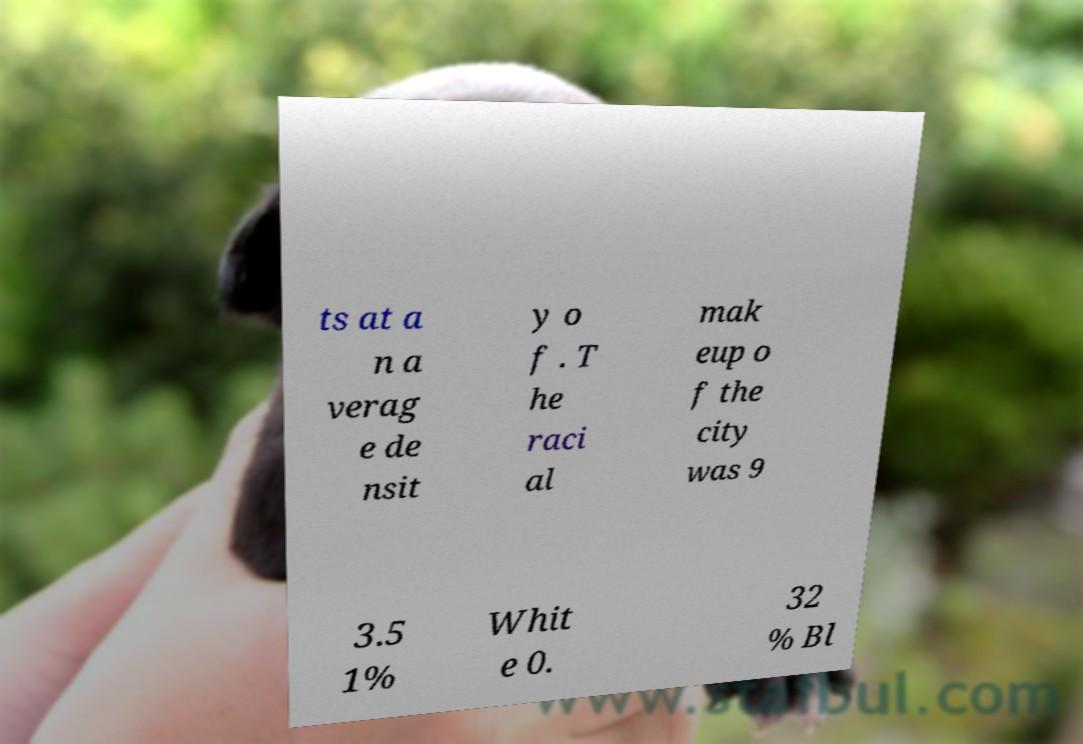What messages or text are displayed in this image? I need them in a readable, typed format. ts at a n a verag e de nsit y o f . T he raci al mak eup o f the city was 9 3.5 1% Whit e 0. 32 % Bl 